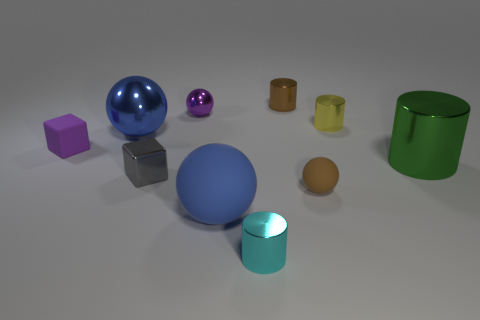Is the shape of the purple thing right of the small gray shiny object the same as  the big green metallic thing?
Provide a succinct answer. No. Do the small metal ball and the tiny shiny cube have the same color?
Offer a terse response. No. How many things are either cubes that are right of the matte cube or small cyan metallic things?
Your answer should be very brief. 2. The purple object that is the same size as the matte cube is what shape?
Offer a very short reply. Sphere. There is a brown thing that is in front of the yellow metal cylinder; does it have the same size as the blue sphere in front of the large blue shiny object?
Make the answer very short. No. What color is the large cylinder that is the same material as the yellow object?
Offer a terse response. Green. Do the cylinder that is behind the purple metal object and the green object in front of the yellow metal object have the same material?
Provide a short and direct response. Yes. Is there a purple matte cube of the same size as the gray object?
Offer a very short reply. Yes. There is a green metal cylinder that is behind the small rubber object that is on the right side of the big rubber sphere; what is its size?
Offer a terse response. Large. How many large things are the same color as the big rubber ball?
Keep it short and to the point. 1. 